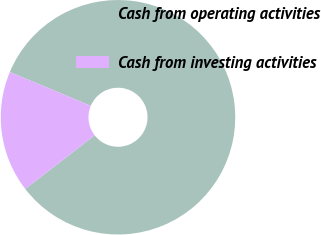<chart> <loc_0><loc_0><loc_500><loc_500><pie_chart><fcel>Cash from operating activities<fcel>Cash from investing activities<nl><fcel>83.22%<fcel>16.78%<nl></chart> 